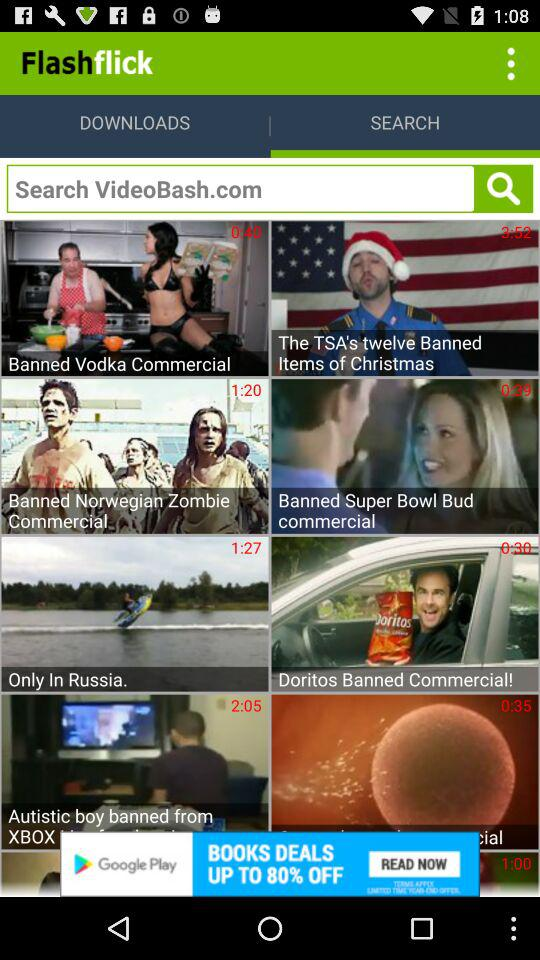What is the application name?
When the provided information is insufficient, respond with <no answer>. <no answer> 